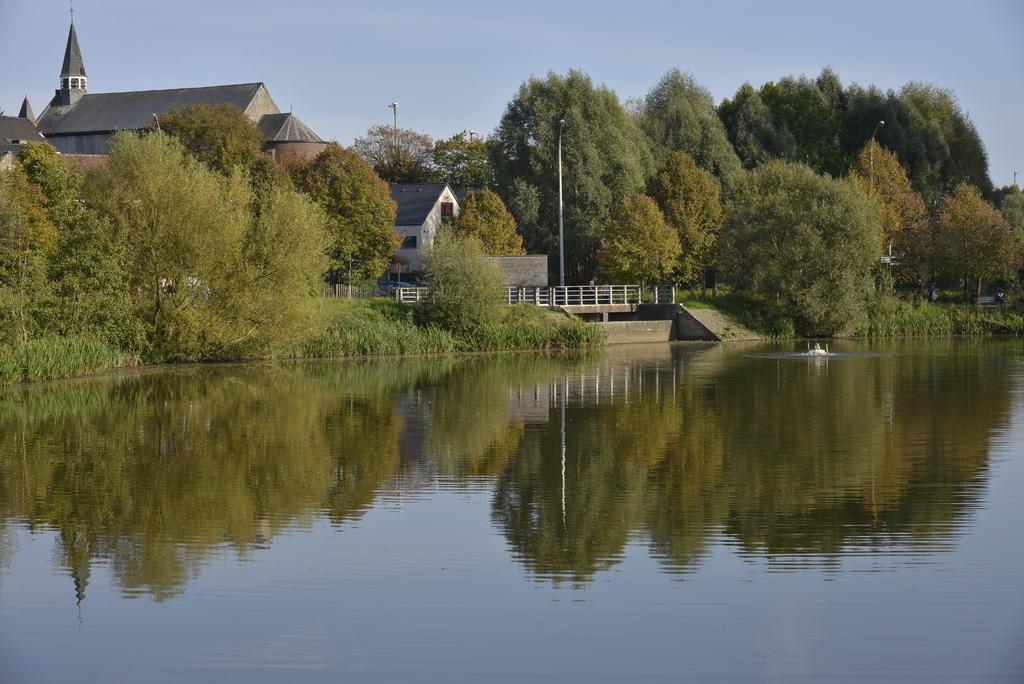Could you give a brief overview of what you see in this image? There is water. In the back there are trees, light poles, buildings, railing and sky. 